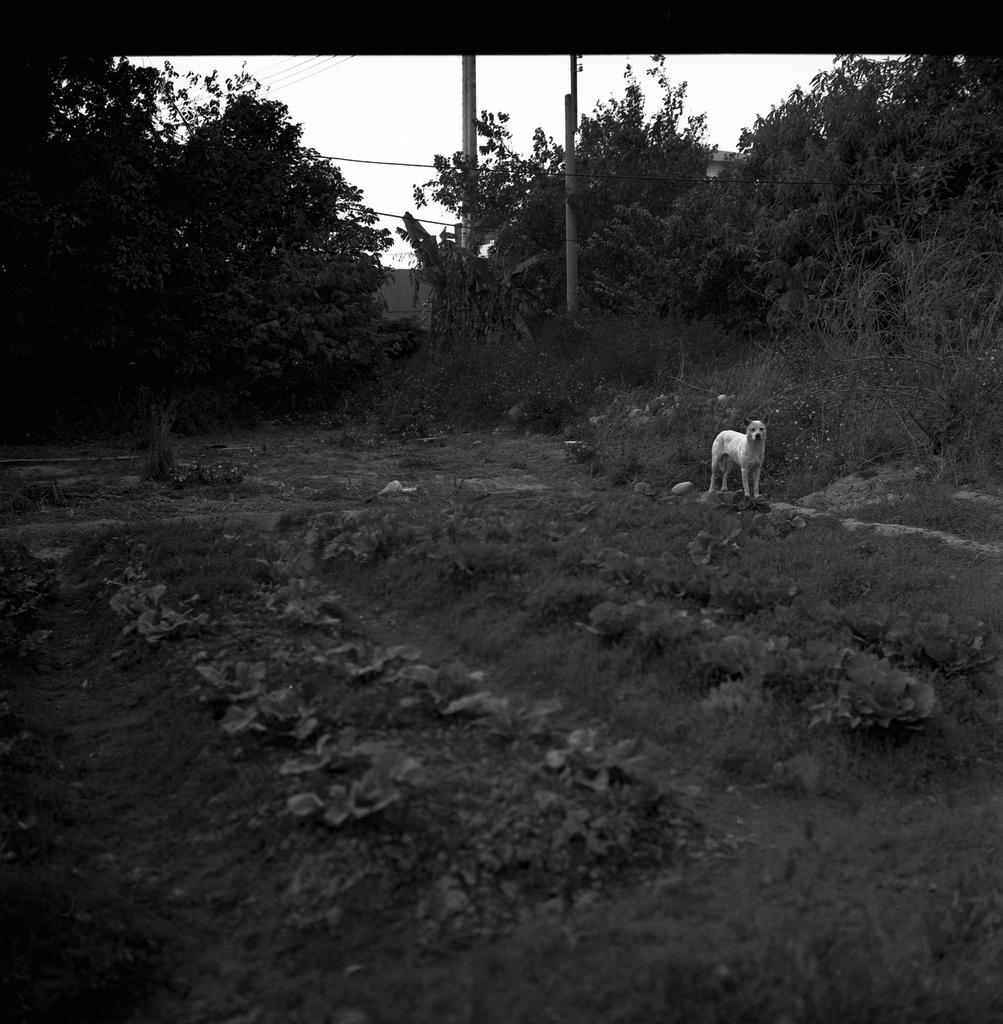Could you give a brief overview of what you see in this image? In this image on the ground there is a dog. In the background there are trees,poles, building and sky. 